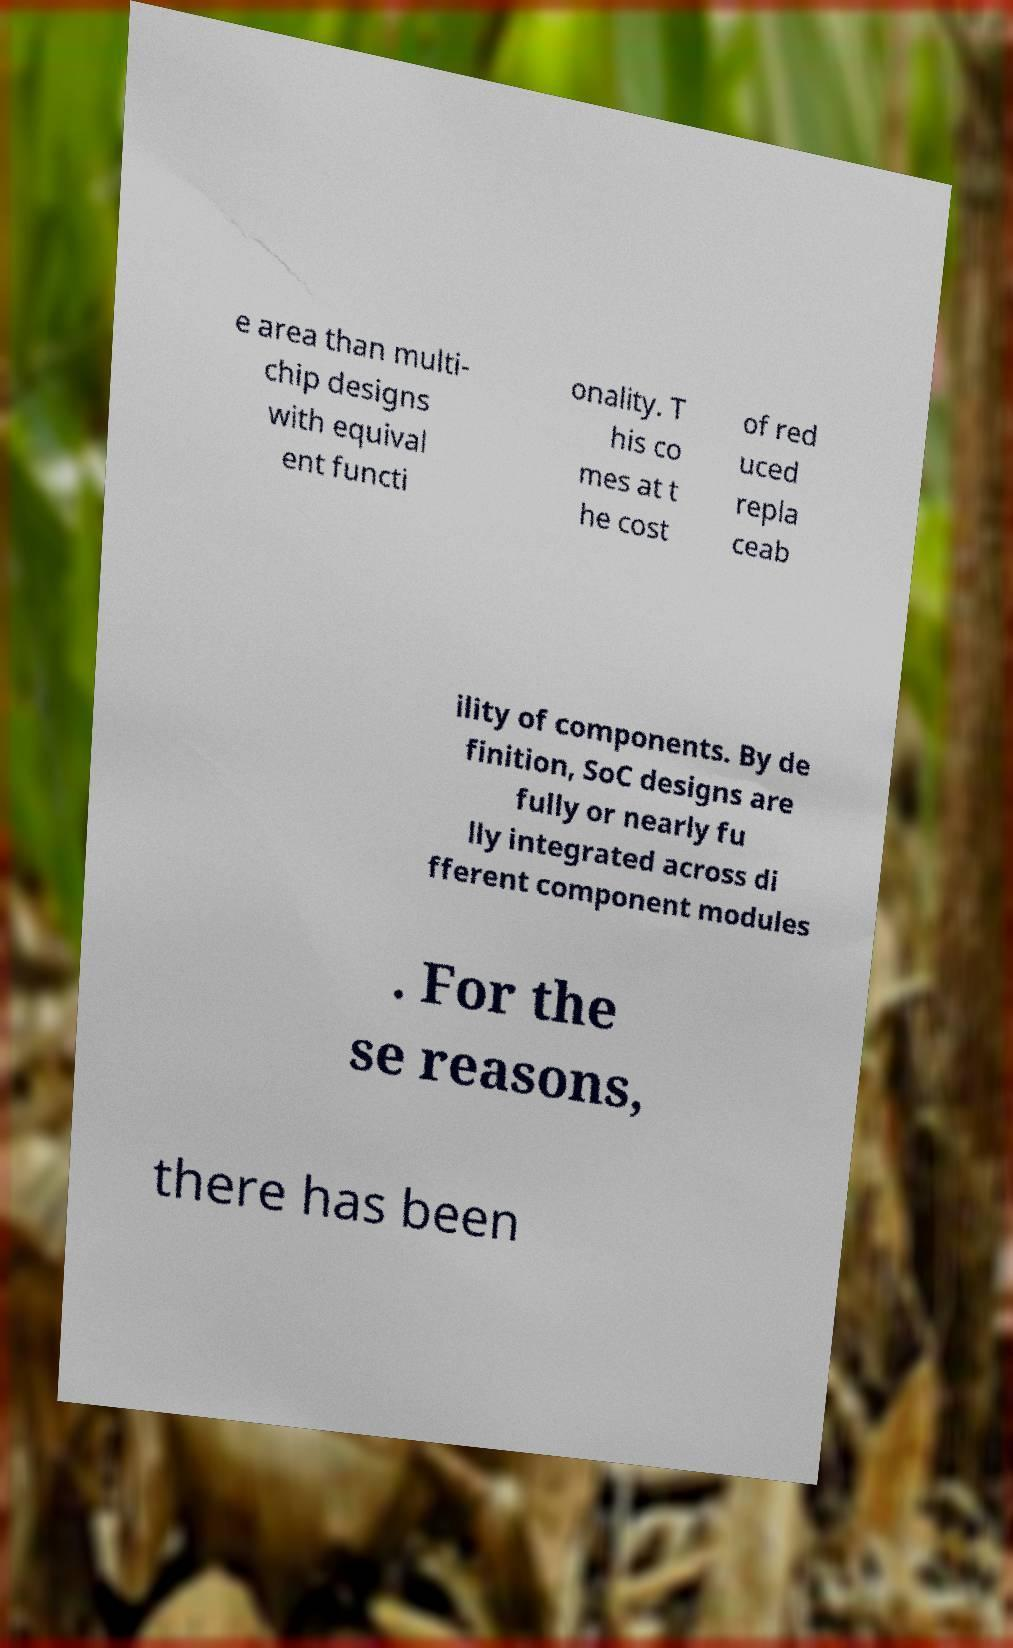Please identify and transcribe the text found in this image. e area than multi- chip designs with equival ent functi onality. T his co mes at t he cost of red uced repla ceab ility of components. By de finition, SoC designs are fully or nearly fu lly integrated across di fferent component modules . For the se reasons, there has been 